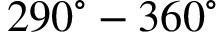Convert formula to latex. <formula><loc_0><loc_0><loc_500><loc_500>2 9 0 ^ { \circ } - 3 6 0 ^ { \circ }</formula> 